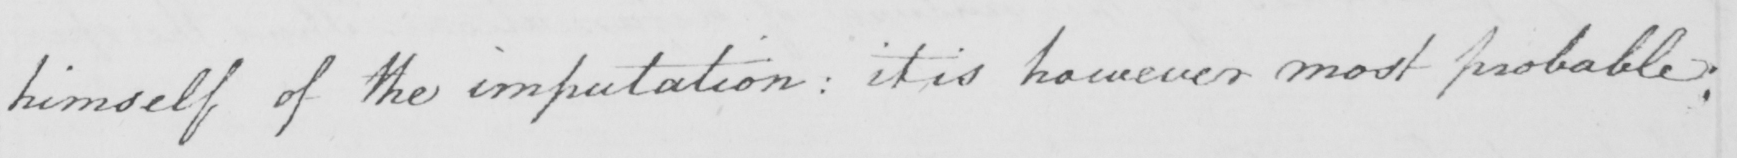Please provide the text content of this handwritten line. himself of the imputation :  it is however most probable : 